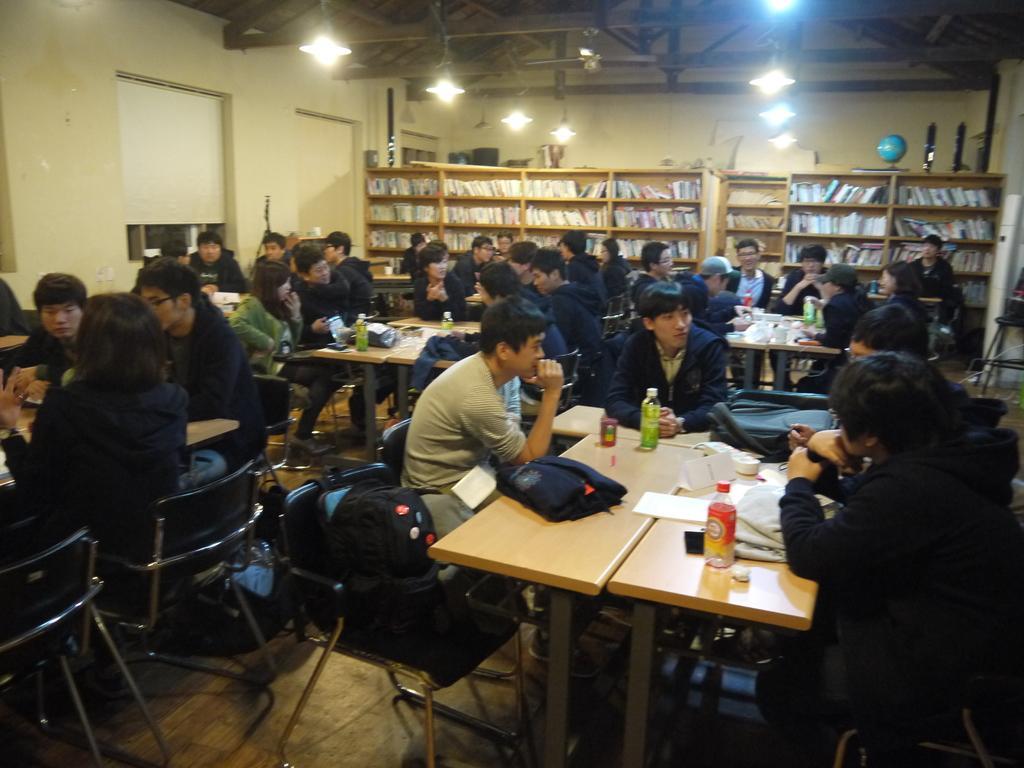Describe this image in one or two sentences. In a room there are many people. They are sitting on a chair. There are some bags. In front of them there is a table. On the table there is a jacket, bottle, paper. In the background there are some cupboards. In the cupboard there are some books. On the cupboard there is a globe. 